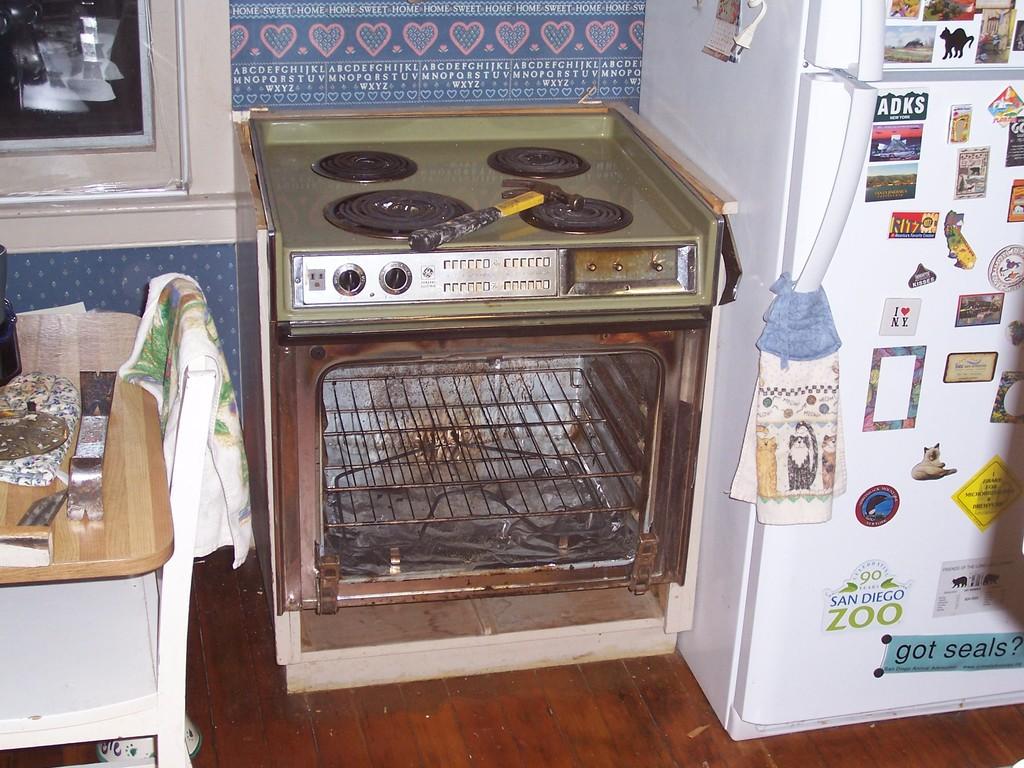What zoo does the fridge magnet advertise?
Ensure brevity in your answer.  San diego. 